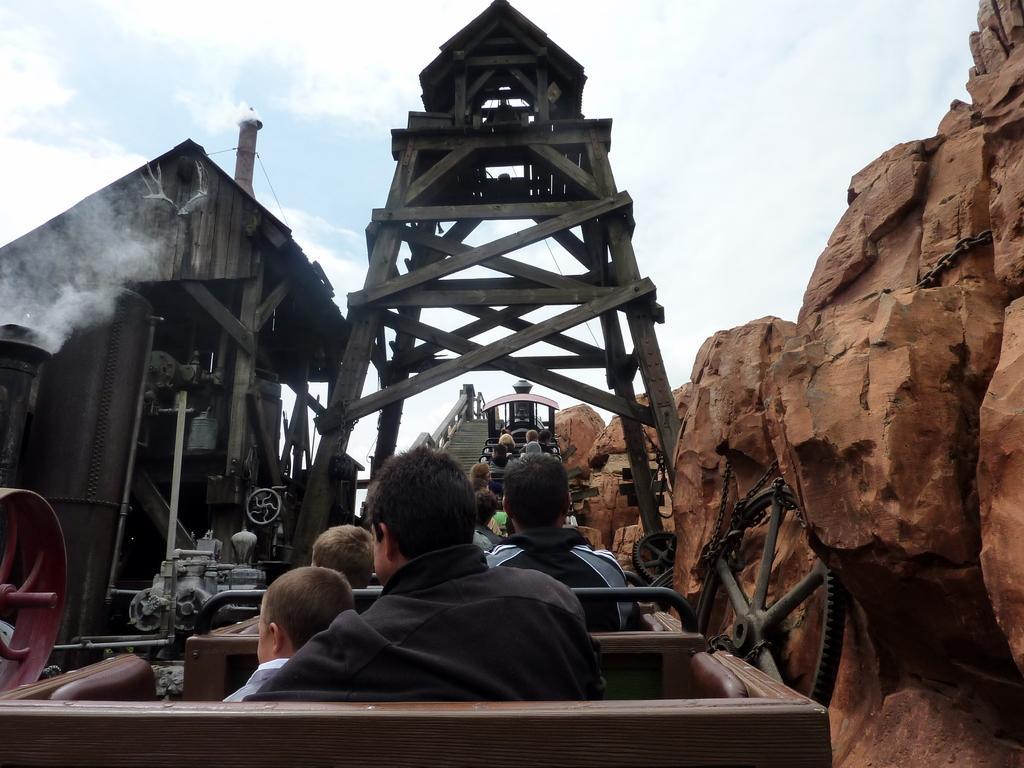Please provide a concise description of this image. In this image we can see one train, some people sitting in the train, one machine under the roof, one object on the wheel, some big rocks on the right side of the image, one wooden tower, some smoke, one chain on the rock and at the top there is the sky. 